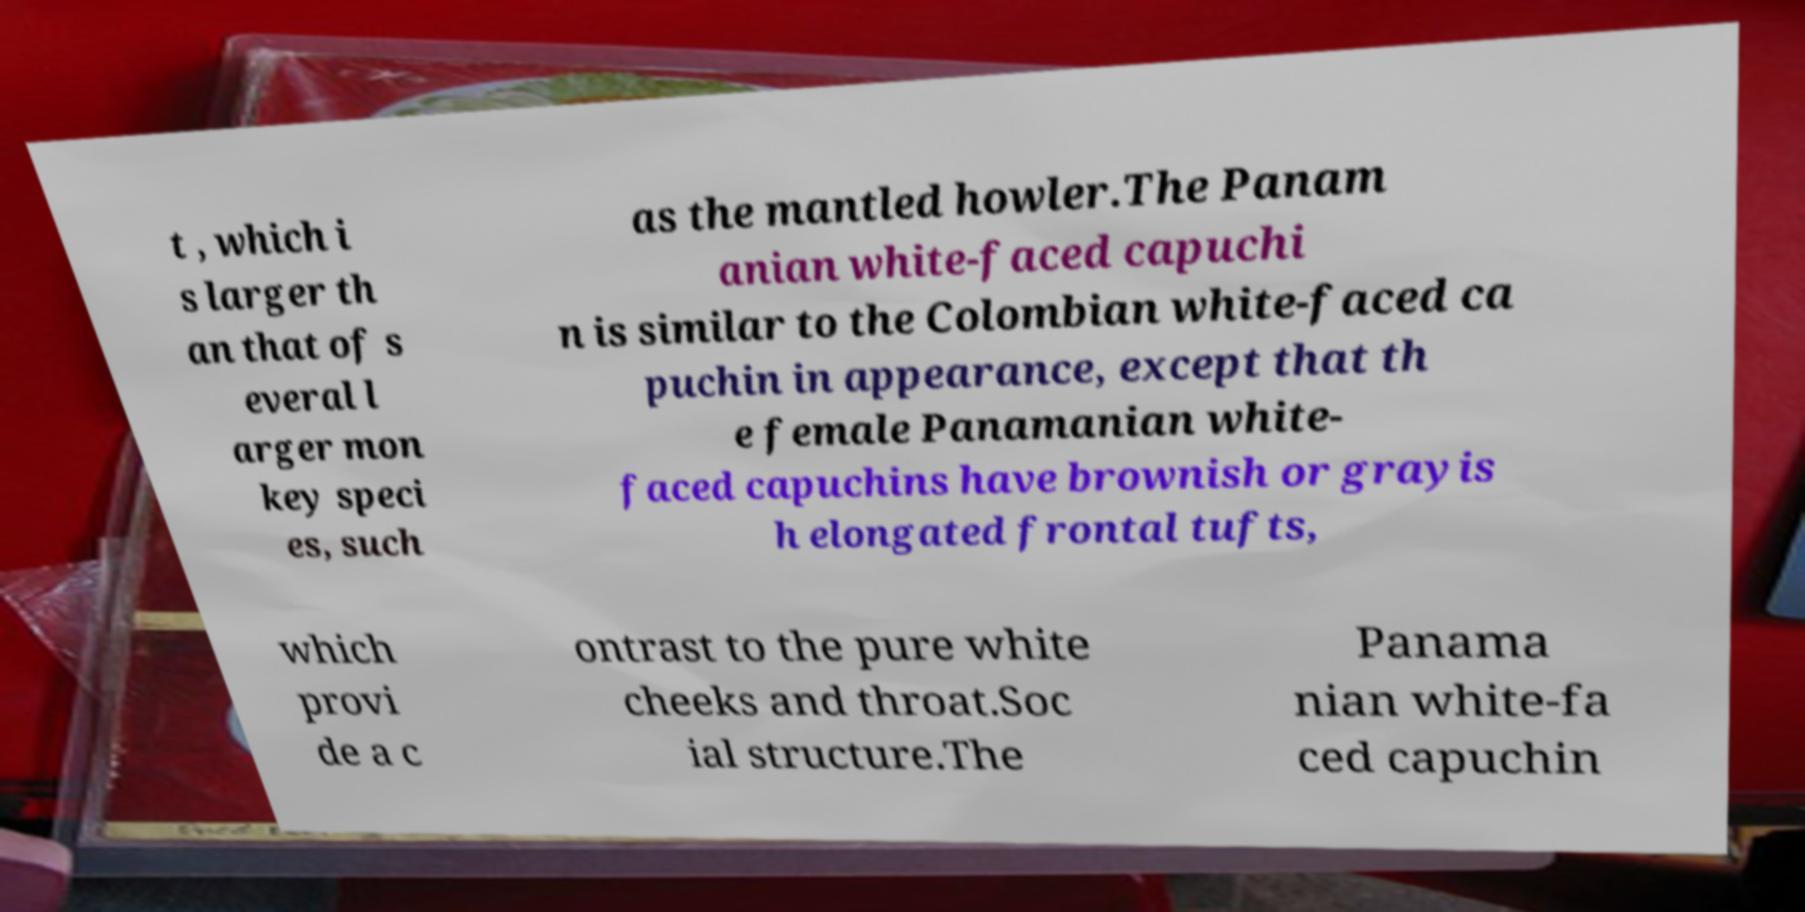What messages or text are displayed in this image? I need them in a readable, typed format. t , which i s larger th an that of s everal l arger mon key speci es, such as the mantled howler.The Panam anian white-faced capuchi n is similar to the Colombian white-faced ca puchin in appearance, except that th e female Panamanian white- faced capuchins have brownish or grayis h elongated frontal tufts, which provi de a c ontrast to the pure white cheeks and throat.Soc ial structure.The Panama nian white-fa ced capuchin 